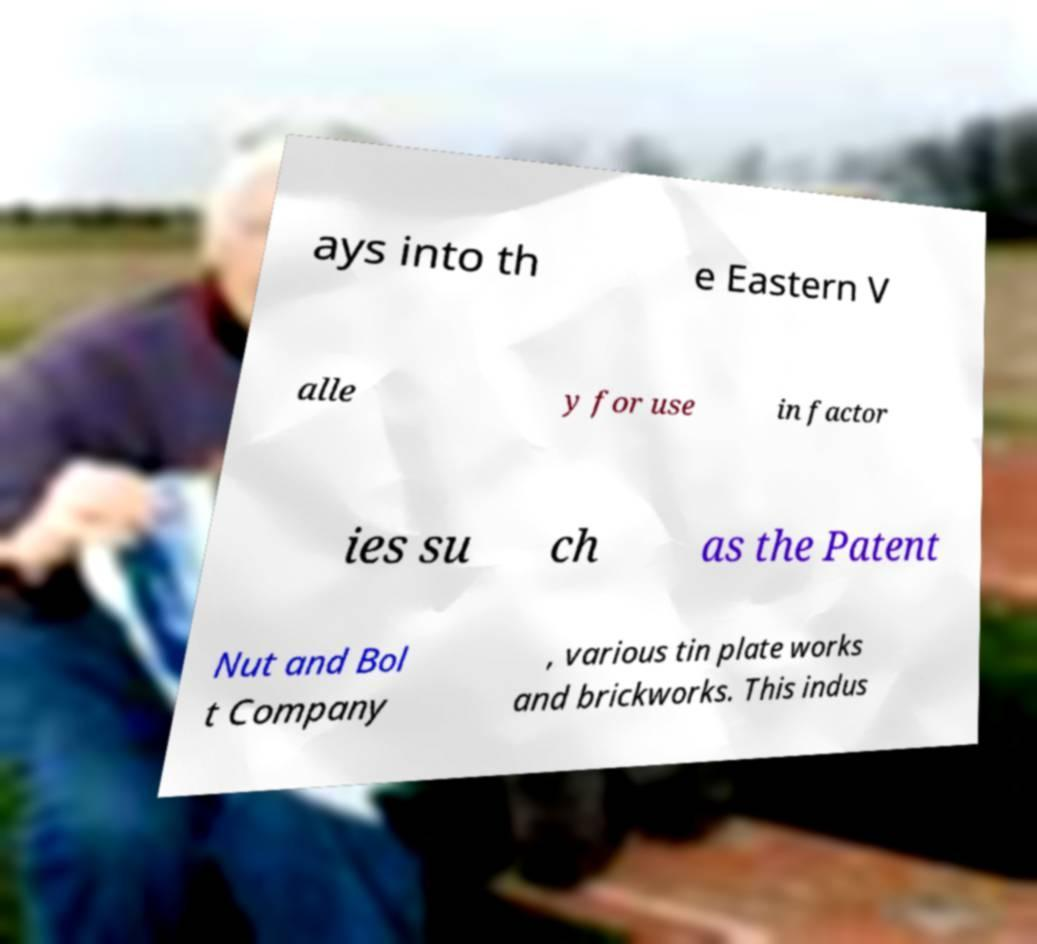Could you assist in decoding the text presented in this image and type it out clearly? ays into th e Eastern V alle y for use in factor ies su ch as the Patent Nut and Bol t Company , various tin plate works and brickworks. This indus 